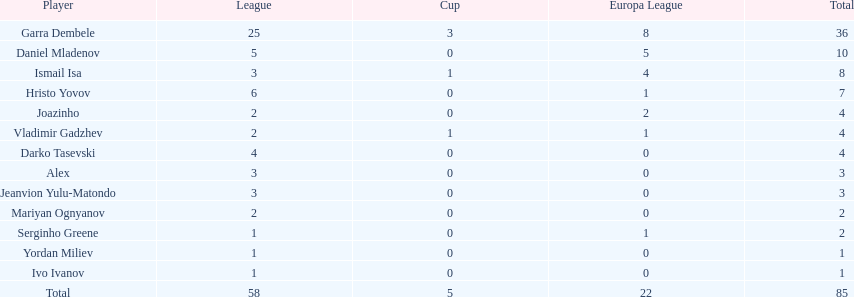How many of the athletes did not score any goals in the cup? 10. Could you parse the entire table? {'header': ['Player', 'League', 'Cup', 'Europa League', 'Total'], 'rows': [['Garra Dembele', '25', '3', '8', '36'], ['Daniel Mladenov', '5', '0', '5', '10'], ['Ismail Isa', '3', '1', '4', '8'], ['Hristo Yovov', '6', '0', '1', '7'], ['Joazinho', '2', '0', '2', '4'], ['Vladimir Gadzhev', '2', '1', '1', '4'], ['Darko Tasevski', '4', '0', '0', '4'], ['Alex', '3', '0', '0', '3'], ['Jeanvion Yulu-Matondo', '3', '0', '0', '3'], ['Mariyan Ognyanov', '2', '0', '0', '2'], ['Serginho Greene', '1', '0', '1', '2'], ['Yordan Miliev', '1', '0', '0', '1'], ['Ivo Ivanov', '1', '0', '0', '1'], ['Total', '58', '5', '22', '85']]} 